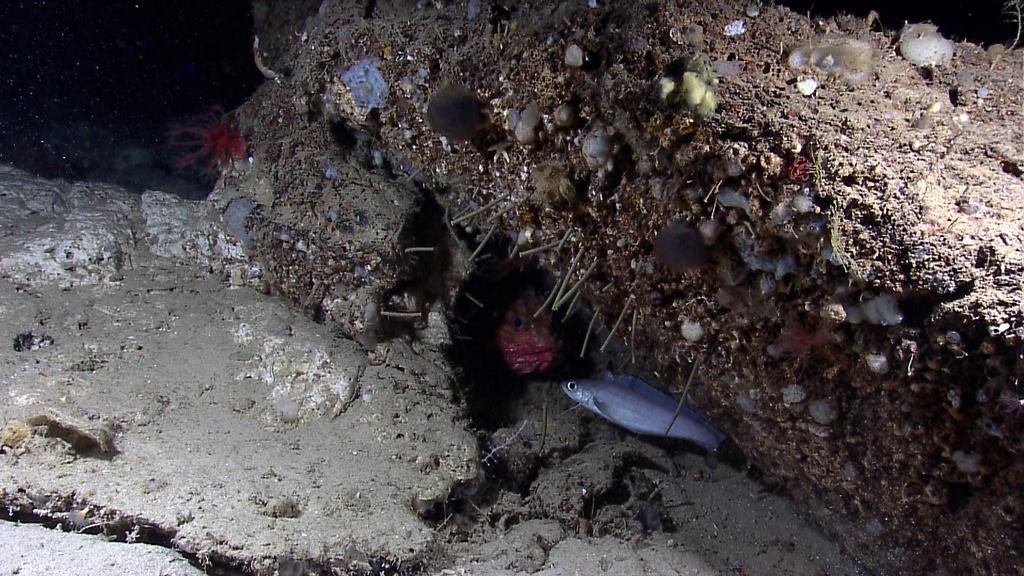In one or two sentences, can you explain what this image depicts? In this image we can see fish in the water and there is soil. 